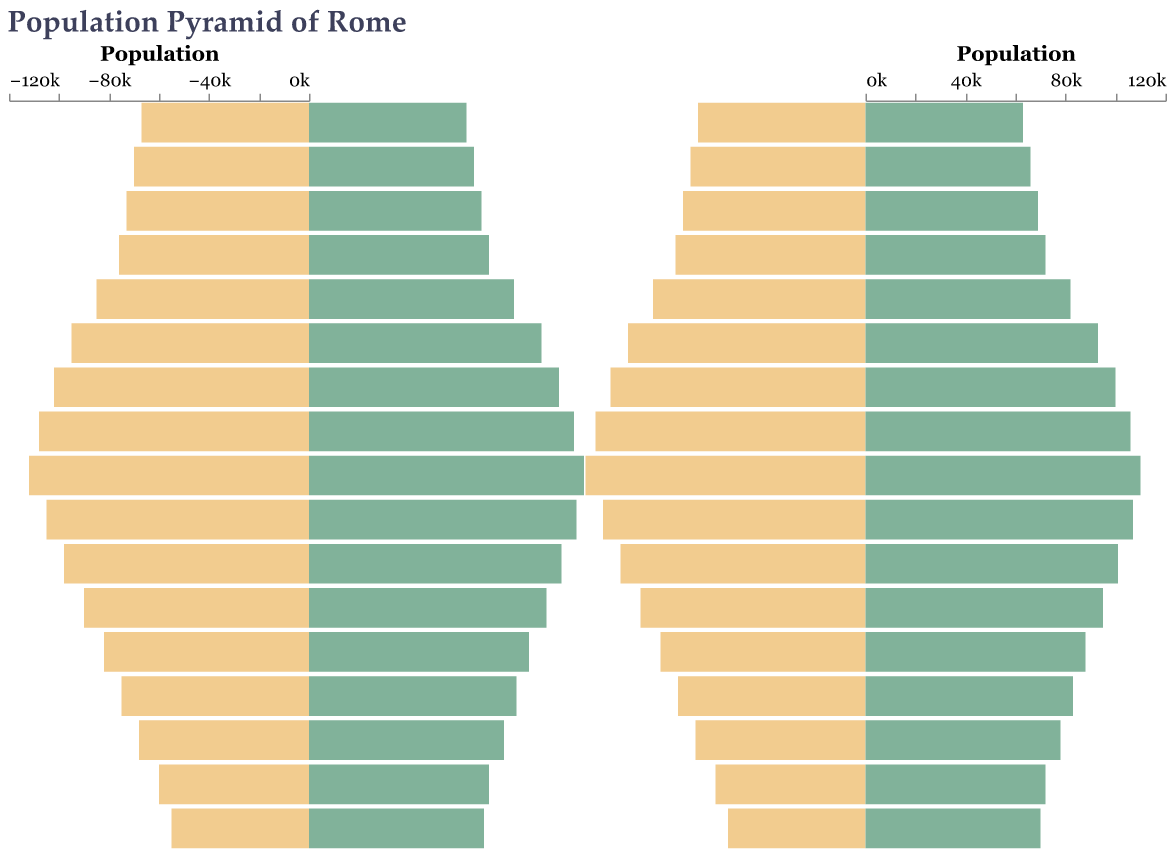Which age group has the highest male population? To find this, look at the height of the bars on the male side and identify the tallest. The age group 40-44 has the tallest bar on the male side.
Answer: 40-44 Which age group has the smallest female population? To find this, look at the height of the bars on the female side and identify the shortest bar. The age group 0-4 has the shortest bar on the female side.
Answer: 0-4 Is there any age group where the female population exceeds the male population? To answer this, compare the values for males and females in each age group. In the age groups 45-49, 60-64, 65-69, and 80+, the female population exceeds the male population.
Answer: Yes, in age groups 45-49, 60-64, 65-69, and 80+ What is the total population for the age group 30-34? Add the male and female populations for the age group 30-34. There are 102,000 males and 100,000 females: 102,000 + 100,000 = 202,000.
Answer: 202,000 In which age group is the gender ratio most balanced? Look for the age group where the male and female populations are closest in number. The age group 25-29 has 95,000 males and 93,000 females, showing the smallest difference.
Answer: 25-29 Which age group has the highest combined population? Add the male and female populations for each age group and identify the highest sum. For age group 35-39, the sum is 108,000 (males) + 106,000 (females) = 214,000, which is the highest combined population.
Answer: 35-39 Compare the population of males in the age group 50-54 to that of females in the same group. Subtract the female population from the male population: 98,000 (males) - 101,000 (females) = -3,000. So, there are 3,000 more females than males in this age group.
Answer: Females outnumber males by 3,000 How does the population trend change from the youngest age group to the oldest for both males and females? Observe the population bars as you move from the youngest (0-4) to the oldest (80+). The population gradually decreases for both males and females with some oscillations, particularly a notable increase as you move to mid-age groups (20-44).
Answer: Decreases with oscillations What is the average population for males across all age groups? First, add the male populations: 67000 + 70000 + 73000 + 76000 + 85000 + 95000 + 102000 + 108000 + 112000 + 105000 + 98000 + 90000 + 82000 + 75000 + 68000 + 60000 + 55000 = 1,451,000. Then, divide this sum by the number of age groups (17): 1,451,000 / 17 ≈ 85,353.
Answer: 85,353 Between ages 20 and 29, which gender shows a higher population, and by how much? Add the populations for each gender in the age groups 20-24 and 25-29: Males: 85,000 + 95,000 = 180,000 Females: 82,000 + 93,000 = 175,000. Males outnumber females by 180,000 - 175,000 = 5,000.
Answer: Males by 5,000 